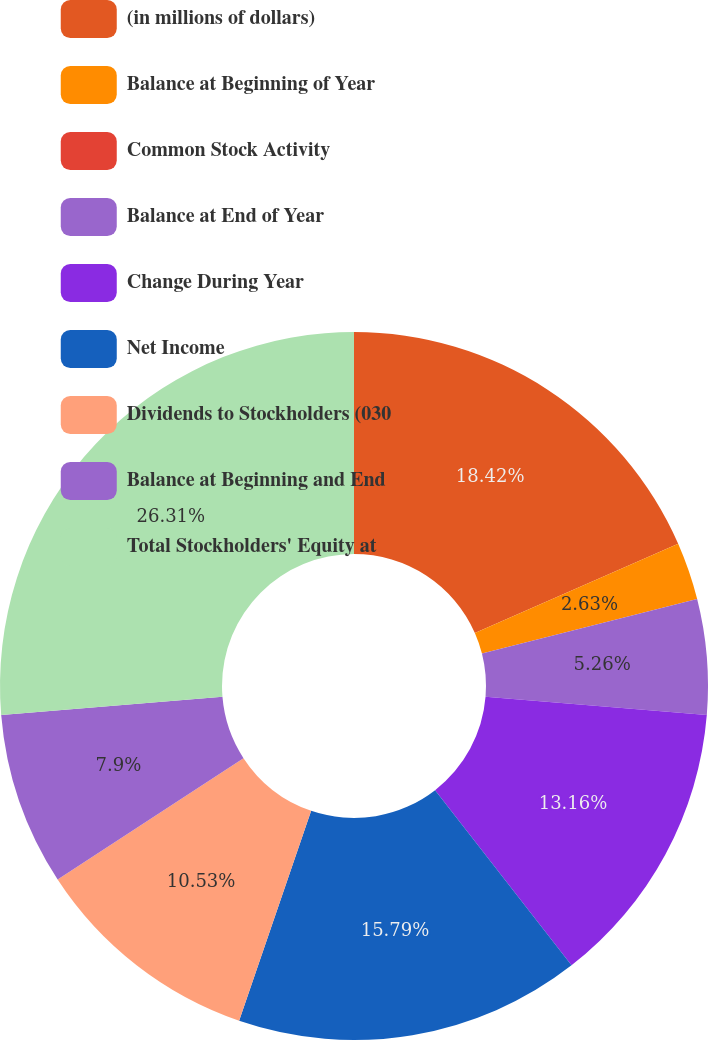Convert chart. <chart><loc_0><loc_0><loc_500><loc_500><pie_chart><fcel>(in millions of dollars)<fcel>Balance at Beginning of Year<fcel>Common Stock Activity<fcel>Balance at End of Year<fcel>Change During Year<fcel>Net Income<fcel>Dividends to Stockholders (030<fcel>Balance at Beginning and End<fcel>Total Stockholders' Equity at<nl><fcel>18.42%<fcel>2.63%<fcel>0.0%<fcel>5.26%<fcel>13.16%<fcel>15.79%<fcel>10.53%<fcel>7.9%<fcel>26.31%<nl></chart> 